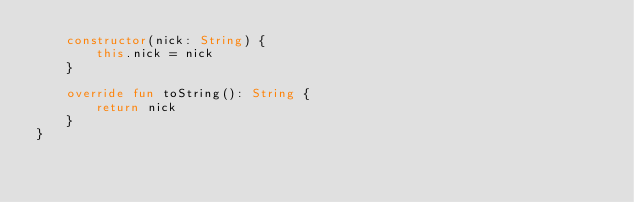<code> <loc_0><loc_0><loc_500><loc_500><_Kotlin_>    constructor(nick: String) {
        this.nick = nick
    }

    override fun toString(): String {
        return nick
    }
}
</code> 